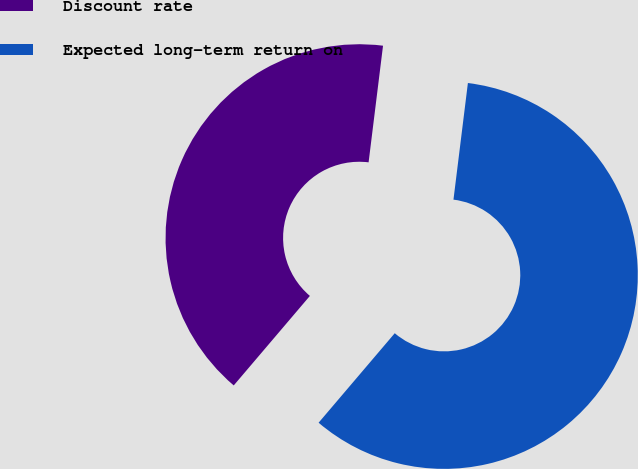Convert chart to OTSL. <chart><loc_0><loc_0><loc_500><loc_500><pie_chart><fcel>Discount rate<fcel>Expected long-term return on<nl><fcel>40.74%<fcel>59.26%<nl></chart> 